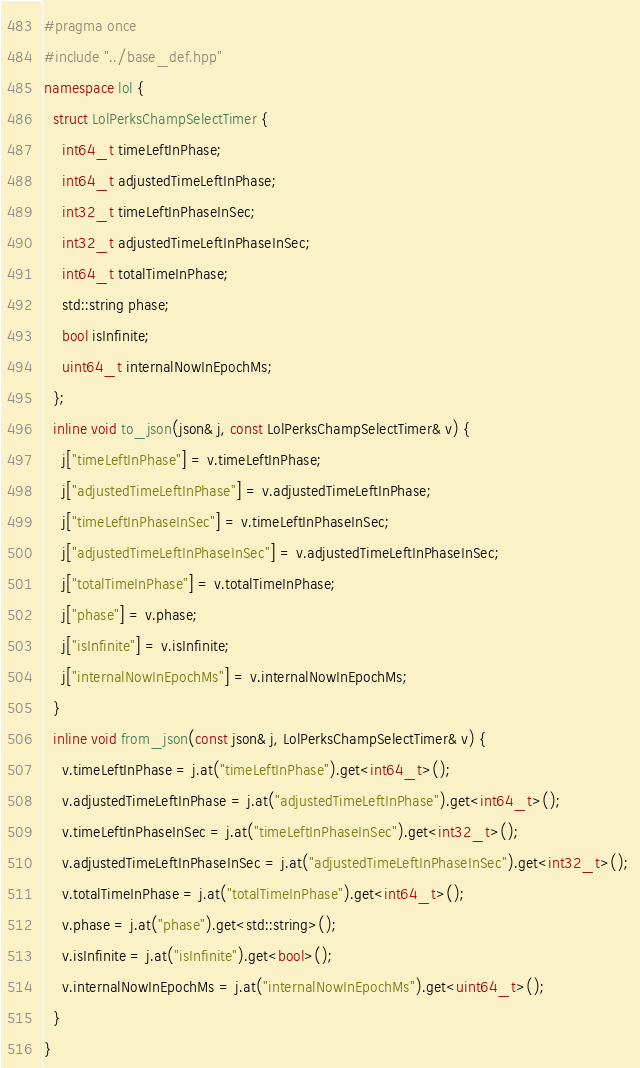Convert code to text. <code><loc_0><loc_0><loc_500><loc_500><_C++_>#pragma once
#include "../base_def.hpp" 
namespace lol {
  struct LolPerksChampSelectTimer { 
    int64_t timeLeftInPhase;
    int64_t adjustedTimeLeftInPhase;
    int32_t timeLeftInPhaseInSec;
    int32_t adjustedTimeLeftInPhaseInSec;
    int64_t totalTimeInPhase;
    std::string phase;
    bool isInfinite;
    uint64_t internalNowInEpochMs; 
  };
  inline void to_json(json& j, const LolPerksChampSelectTimer& v) {
    j["timeLeftInPhase"] = v.timeLeftInPhase; 
    j["adjustedTimeLeftInPhase"] = v.adjustedTimeLeftInPhase; 
    j["timeLeftInPhaseInSec"] = v.timeLeftInPhaseInSec; 
    j["adjustedTimeLeftInPhaseInSec"] = v.adjustedTimeLeftInPhaseInSec; 
    j["totalTimeInPhase"] = v.totalTimeInPhase; 
    j["phase"] = v.phase; 
    j["isInfinite"] = v.isInfinite; 
    j["internalNowInEpochMs"] = v.internalNowInEpochMs; 
  }
  inline void from_json(const json& j, LolPerksChampSelectTimer& v) {
    v.timeLeftInPhase = j.at("timeLeftInPhase").get<int64_t>(); 
    v.adjustedTimeLeftInPhase = j.at("adjustedTimeLeftInPhase").get<int64_t>(); 
    v.timeLeftInPhaseInSec = j.at("timeLeftInPhaseInSec").get<int32_t>(); 
    v.adjustedTimeLeftInPhaseInSec = j.at("adjustedTimeLeftInPhaseInSec").get<int32_t>(); 
    v.totalTimeInPhase = j.at("totalTimeInPhase").get<int64_t>(); 
    v.phase = j.at("phase").get<std::string>(); 
    v.isInfinite = j.at("isInfinite").get<bool>(); 
    v.internalNowInEpochMs = j.at("internalNowInEpochMs").get<uint64_t>(); 
  }
}</code> 